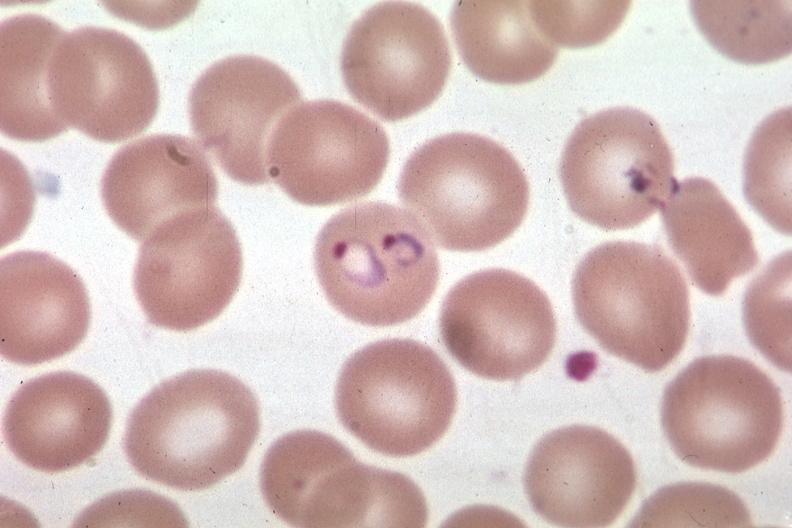s wonder present?
Answer the question using a single word or phrase. No 